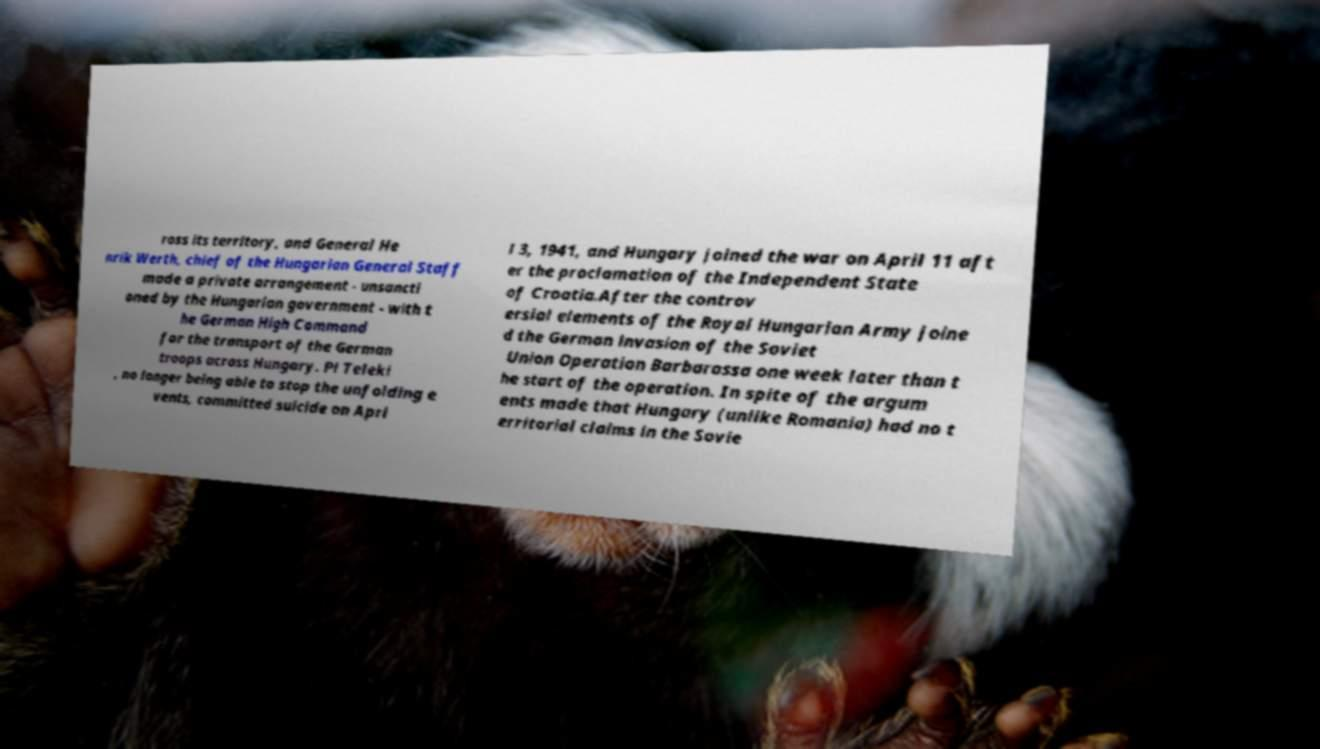What messages or text are displayed in this image? I need them in a readable, typed format. ross its territory, and General He nrik Werth, chief of the Hungarian General Staff made a private arrangement - unsancti oned by the Hungarian government - with t he German High Command for the transport of the German troops across Hungary. Pl Teleki , no longer being able to stop the unfolding e vents, committed suicide on Apri l 3, 1941, and Hungary joined the war on April 11 aft er the proclamation of the Independent State of Croatia.After the controv ersial elements of the Royal Hungarian Army joine d the German invasion of the Soviet Union Operation Barbarossa one week later than t he start of the operation. In spite of the argum ents made that Hungary (unlike Romania) had no t erritorial claims in the Sovie 